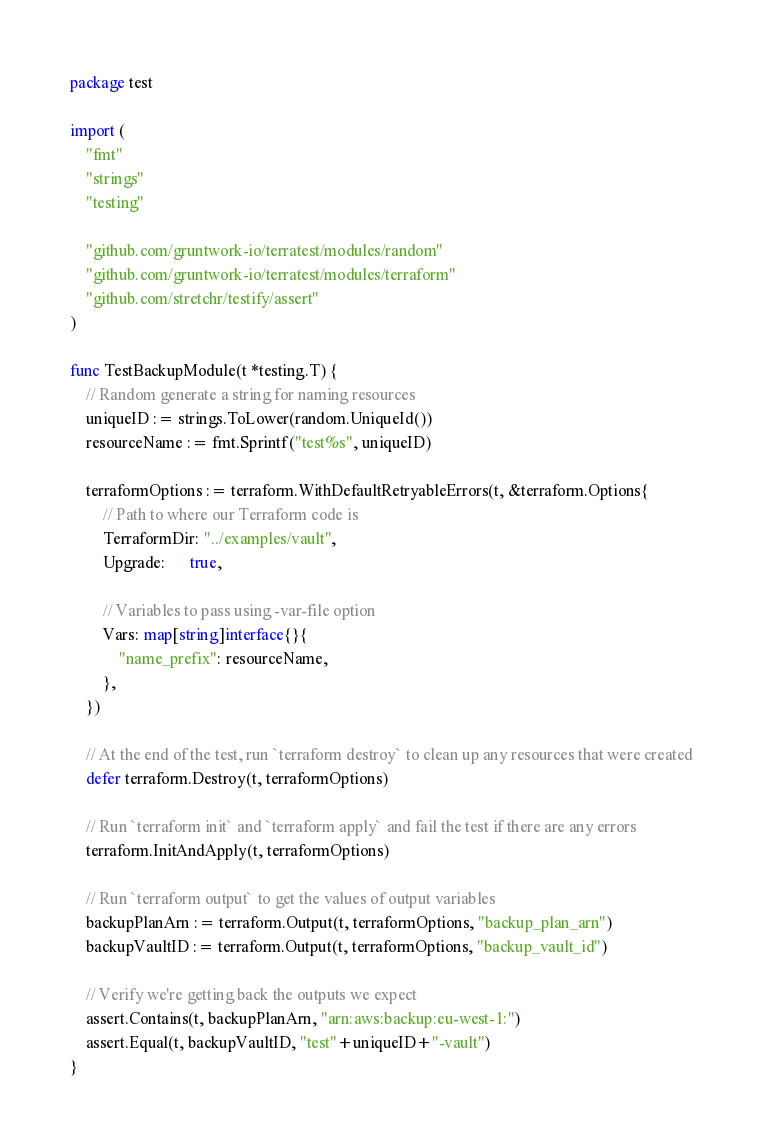<code> <loc_0><loc_0><loc_500><loc_500><_Go_>package test

import (
	"fmt"
	"strings"
	"testing"

	"github.com/gruntwork-io/terratest/modules/random"
	"github.com/gruntwork-io/terratest/modules/terraform"
	"github.com/stretchr/testify/assert"
)

func TestBackupModule(t *testing.T) {
	// Random generate a string for naming resources
	uniqueID := strings.ToLower(random.UniqueId())
	resourceName := fmt.Sprintf("test%s", uniqueID)

	terraformOptions := terraform.WithDefaultRetryableErrors(t, &terraform.Options{
		// Path to where our Terraform code is
		TerraformDir: "../examples/vault",
		Upgrade:      true,

		// Variables to pass using -var-file option
		Vars: map[string]interface{}{
			"name_prefix": resourceName,
		},
	})

	// At the end of the test, run `terraform destroy` to clean up any resources that were created
	defer terraform.Destroy(t, terraformOptions)

	// Run `terraform init` and `terraform apply` and fail the test if there are any errors
	terraform.InitAndApply(t, terraformOptions)

	// Run `terraform output` to get the values of output variables
	backupPlanArn := terraform.Output(t, terraformOptions, "backup_plan_arn")
	backupVaultID := terraform.Output(t, terraformOptions, "backup_vault_id")

	// Verify we're getting back the outputs we expect
	assert.Contains(t, backupPlanArn, "arn:aws:backup:eu-west-1:")
	assert.Equal(t, backupVaultID, "test"+uniqueID+"-vault")
}
</code> 